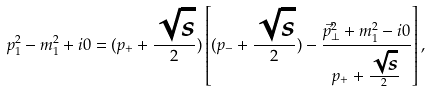<formula> <loc_0><loc_0><loc_500><loc_500>p _ { 1 } ^ { 2 } - m _ { 1 } ^ { 2 } + i 0 = ( p _ { + } + \frac { \sqrt { s } } { 2 } ) \left [ ( p _ { - } + \frac { \sqrt { s } } { 2 } ) - \frac { \vec { p } _ { \perp } ^ { 2 } + m _ { 1 } ^ { 2 } - i 0 } { p _ { + } + \frac { \sqrt { s } } { 2 } } \right ] ,</formula> 